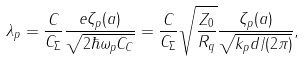<formula> <loc_0><loc_0><loc_500><loc_500>\lambda _ { p } = \frac { C } { C _ { \Sigma } } \frac { e \zeta _ { p } ( a ) } { \sqrt { 2 \hbar { \omega } _ { p } C _ { C } } } = \frac { C } { C _ { \Sigma } } \sqrt { \frac { Z _ { 0 } } { R _ { q } } } \frac { \zeta _ { p } ( a ) } { \sqrt { k _ { p } d / ( 2 \pi ) } } ,</formula> 